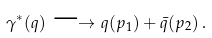Convert formula to latex. <formula><loc_0><loc_0><loc_500><loc_500>\gamma ^ { * } ( q ) \longrightarrow q ( p _ { 1 } ) + \bar { q } ( p _ { 2 } ) \, .</formula> 